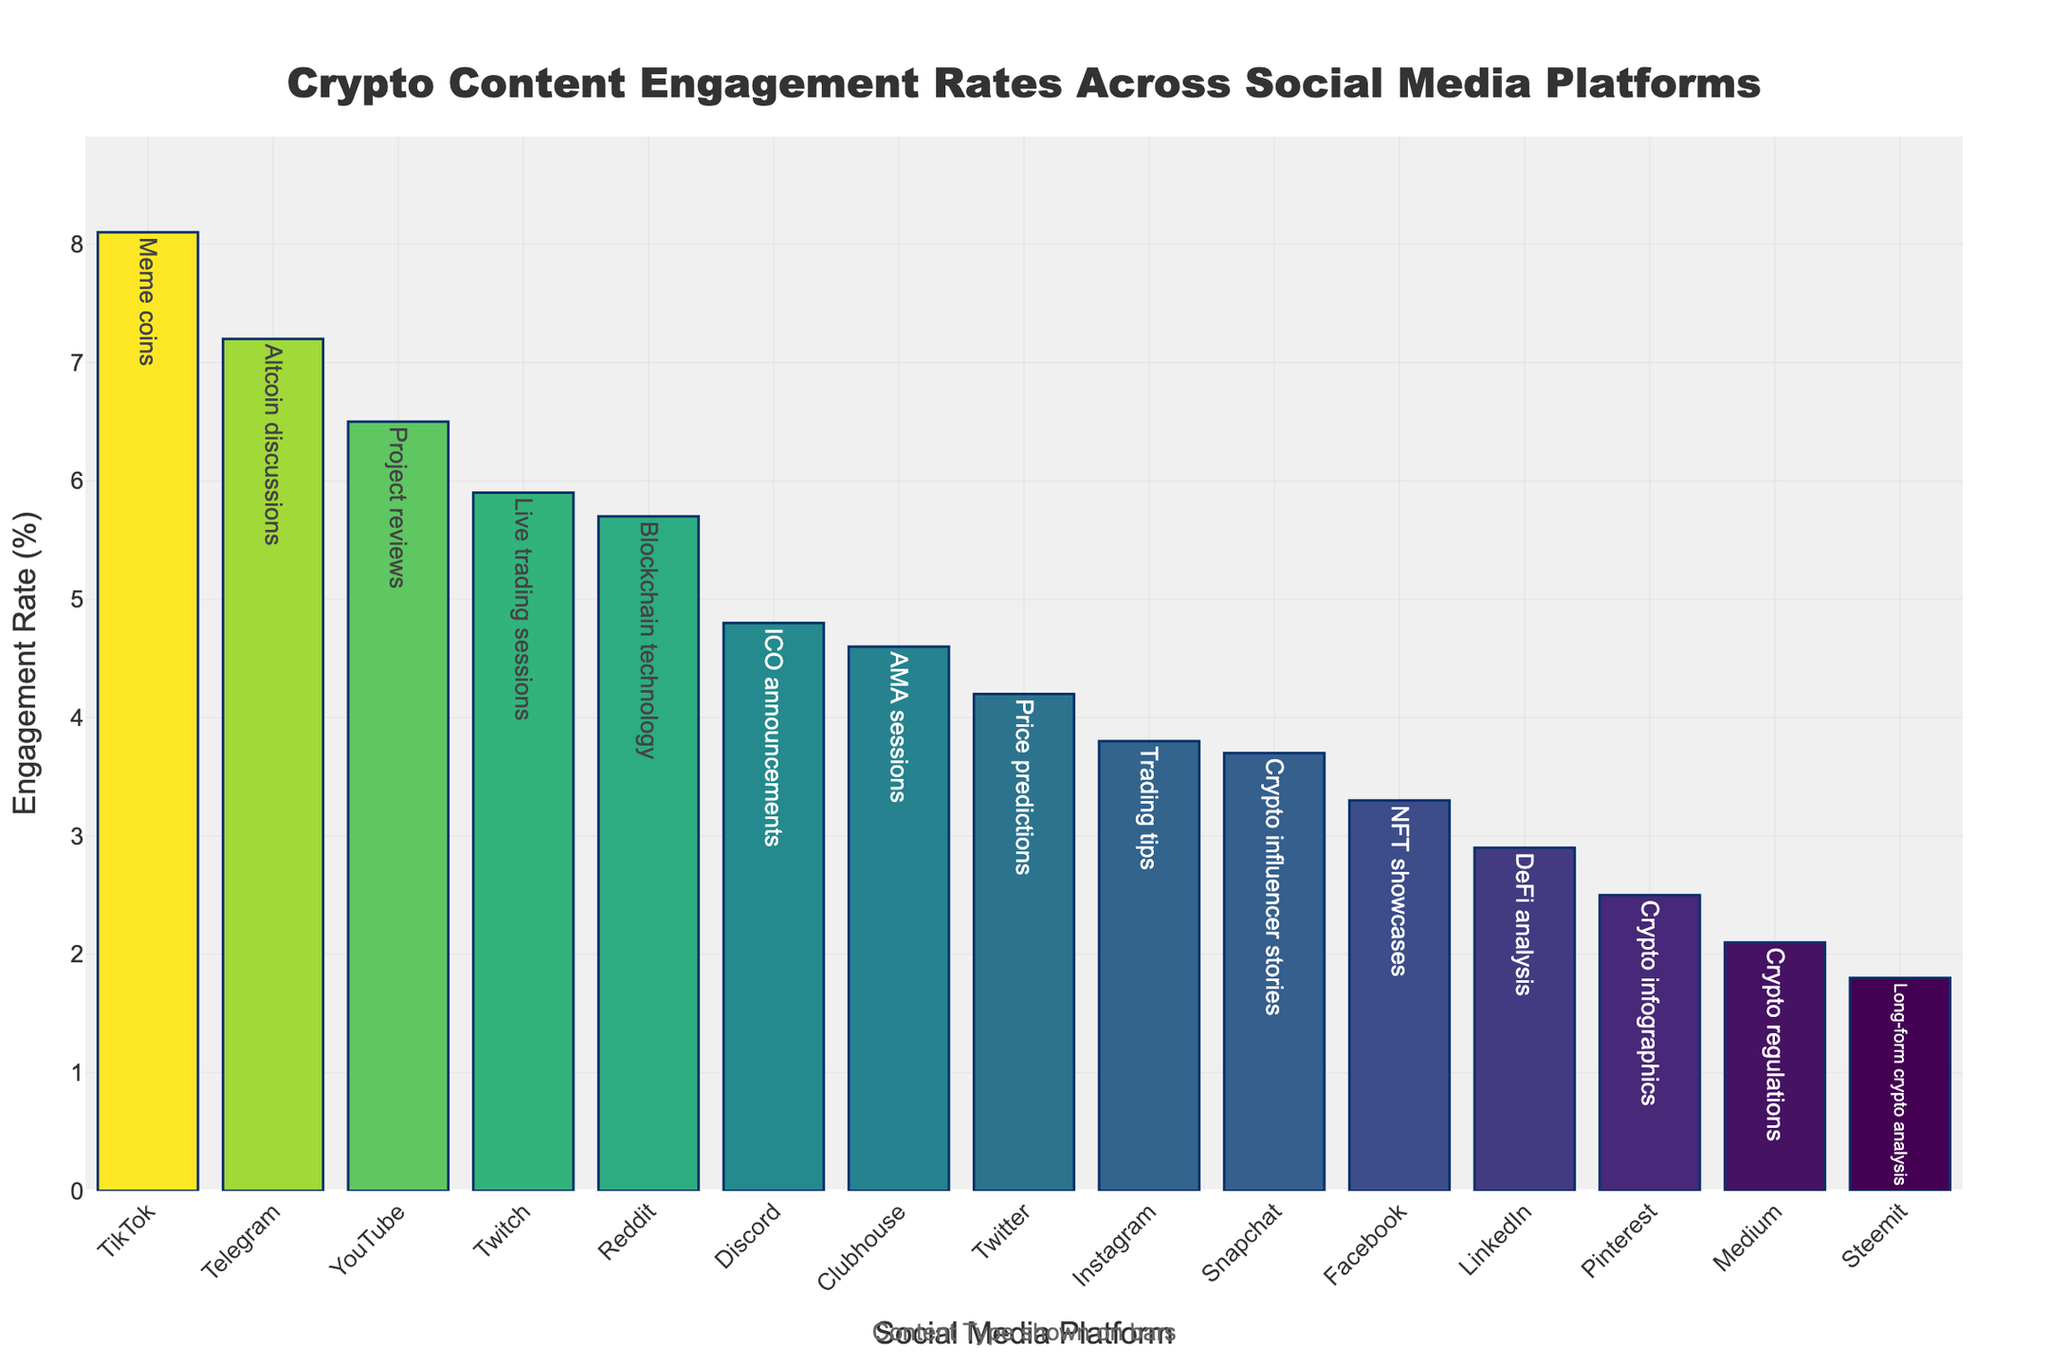Which social media platform has the highest engagement rate for crypto content? The bar for TikTok is the tallest, indicating the highest engagement rate for crypto content.
Answer: TikTok How does the engagement rate of Reddit compare to that of Instagram? The engagement rate for Reddit is higher than that for Instagram, as the bar for Reddit is taller than the bar for Instagram.
Answer: Reddit has a higher engagement rate What is the difference in engagement rate between YouTube and Medium? Subtract Medium's rate (2.1%) from YouTube's rate (6.5%). The difference is 6.5% - 2.1% = 4.4%.
Answer: 4.4% Which content type has the lowest engagement rate, and on which platform is it posted? The bar representing Steemit has the shortest height, indicating it has the lowest engagement rate for Long-form crypto analysis.
Answer: Steemit, Long-form crypto analysis What is the average engagement rate of Facebook and LinkedIn? Add the engagement rates of Facebook (3.3%) and LinkedIn (2.9%), then divide by 2: (3.3% + 2.9%) / 2 = 3.1%.
Answer: 3.1% Which social media platform has an engagement rate closest to 5%? The bar for Twitch is closest to the 5% mark, indicating an engagement rate close to 5%.
Answer: Twitch If the sum of engagement rates for Twitter, Instagram, and YouTube is calculated, what would it be? Add the engagement rates: Twitter (4.2%), Instagram (3.8%), YouTube (6.5%): 4.2% + 3.8% + 6.5% = 14.5%.
Answer: 14.5% Are there more platforms with engagement rates above 5% or below 5%? Count the bars above 5% (YouTube, TikTok, Reddit, Telegram, Twitch) and those below 5% (Twitter, Instagram, LinkedIn, Facebook, Medium, Pinterest, Clubhouse, Snapchat, Steemit). There are 5 above and 9 below.
Answer: Below 5% 